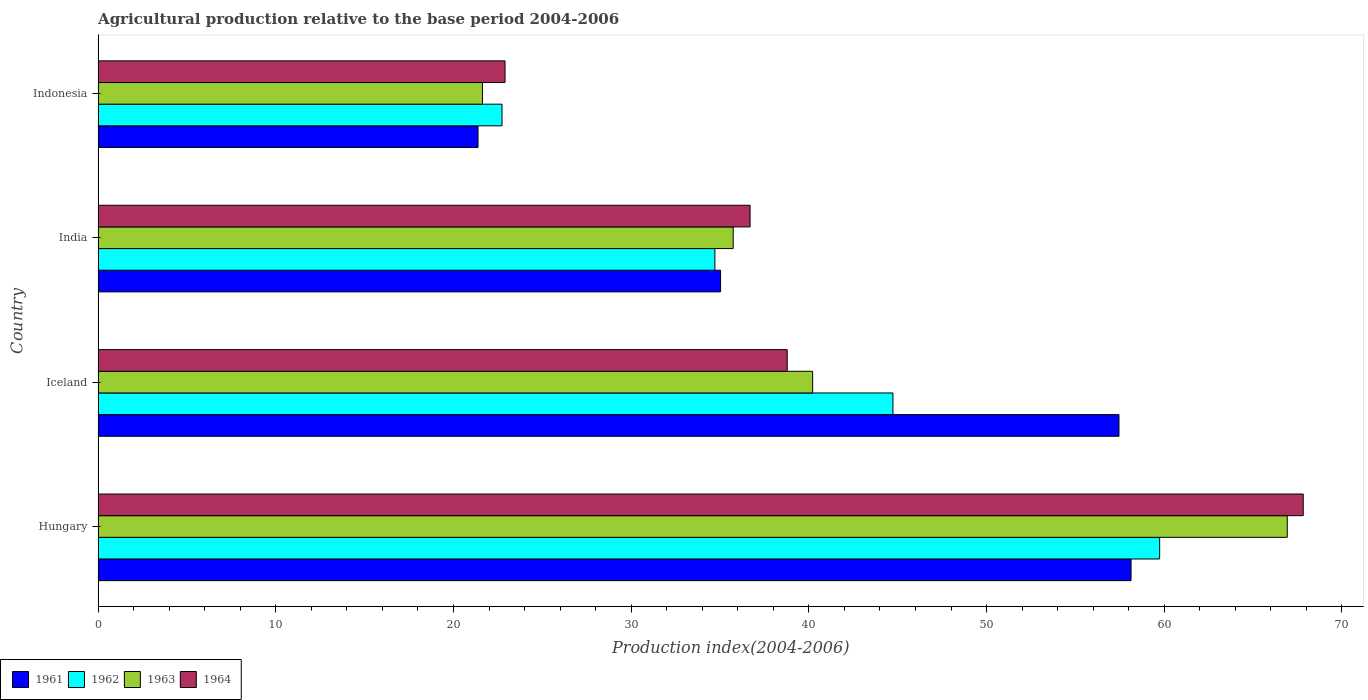How many different coloured bars are there?
Offer a terse response. 4. Are the number of bars on each tick of the Y-axis equal?
Make the answer very short. Yes. How many bars are there on the 4th tick from the top?
Give a very brief answer. 4. What is the label of the 4th group of bars from the top?
Offer a terse response. Hungary. In how many cases, is the number of bars for a given country not equal to the number of legend labels?
Provide a succinct answer. 0. What is the agricultural production index in 1963 in Indonesia?
Your response must be concise. 21.63. Across all countries, what is the maximum agricultural production index in 1962?
Make the answer very short. 59.74. Across all countries, what is the minimum agricultural production index in 1963?
Provide a short and direct response. 21.63. In which country was the agricultural production index in 1962 maximum?
Offer a very short reply. Hungary. In which country was the agricultural production index in 1961 minimum?
Offer a very short reply. Indonesia. What is the total agricultural production index in 1962 in the graph?
Make the answer very short. 161.91. What is the difference between the agricultural production index in 1961 in India and that in Indonesia?
Offer a very short reply. 13.65. What is the difference between the agricultural production index in 1963 in Hungary and the agricultural production index in 1962 in Indonesia?
Your response must be concise. 44.19. What is the average agricultural production index in 1963 per country?
Your answer should be very brief. 41.12. What is the difference between the agricultural production index in 1963 and agricultural production index in 1961 in Indonesia?
Offer a terse response. 0.25. What is the ratio of the agricultural production index in 1964 in Iceland to that in India?
Give a very brief answer. 1.06. What is the difference between the highest and the second highest agricultural production index in 1962?
Make the answer very short. 15.01. What is the difference between the highest and the lowest agricultural production index in 1963?
Provide a short and direct response. 45.29. In how many countries, is the agricultural production index in 1961 greater than the average agricultural production index in 1961 taken over all countries?
Offer a terse response. 2. Is the sum of the agricultural production index in 1964 in Hungary and India greater than the maximum agricultural production index in 1961 across all countries?
Provide a short and direct response. Yes. Is it the case that in every country, the sum of the agricultural production index in 1961 and agricultural production index in 1963 is greater than the sum of agricultural production index in 1964 and agricultural production index in 1962?
Your answer should be compact. No. What does the 2nd bar from the bottom in Iceland represents?
Make the answer very short. 1962. Are all the bars in the graph horizontal?
Keep it short and to the point. Yes. Does the graph contain any zero values?
Your response must be concise. No. Where does the legend appear in the graph?
Ensure brevity in your answer.  Bottom left. How are the legend labels stacked?
Ensure brevity in your answer.  Horizontal. What is the title of the graph?
Your answer should be compact. Agricultural production relative to the base period 2004-2006. What is the label or title of the X-axis?
Offer a very short reply. Production index(2004-2006). What is the label or title of the Y-axis?
Offer a very short reply. Country. What is the Production index(2004-2006) of 1961 in Hungary?
Offer a terse response. 58.13. What is the Production index(2004-2006) in 1962 in Hungary?
Make the answer very short. 59.74. What is the Production index(2004-2006) in 1963 in Hungary?
Keep it short and to the point. 66.92. What is the Production index(2004-2006) of 1964 in Hungary?
Make the answer very short. 67.82. What is the Production index(2004-2006) of 1961 in Iceland?
Provide a succinct answer. 57.45. What is the Production index(2004-2006) of 1962 in Iceland?
Offer a very short reply. 44.73. What is the Production index(2004-2006) in 1963 in Iceland?
Your answer should be compact. 40.21. What is the Production index(2004-2006) in 1964 in Iceland?
Your answer should be compact. 38.78. What is the Production index(2004-2006) in 1961 in India?
Offer a very short reply. 35.03. What is the Production index(2004-2006) of 1962 in India?
Your answer should be very brief. 34.71. What is the Production index(2004-2006) of 1963 in India?
Offer a very short reply. 35.74. What is the Production index(2004-2006) of 1964 in India?
Offer a very short reply. 36.69. What is the Production index(2004-2006) of 1961 in Indonesia?
Offer a very short reply. 21.38. What is the Production index(2004-2006) in 1962 in Indonesia?
Provide a succinct answer. 22.73. What is the Production index(2004-2006) in 1963 in Indonesia?
Offer a very short reply. 21.63. What is the Production index(2004-2006) in 1964 in Indonesia?
Your response must be concise. 22.9. Across all countries, what is the maximum Production index(2004-2006) of 1961?
Keep it short and to the point. 58.13. Across all countries, what is the maximum Production index(2004-2006) in 1962?
Provide a short and direct response. 59.74. Across all countries, what is the maximum Production index(2004-2006) in 1963?
Offer a very short reply. 66.92. Across all countries, what is the maximum Production index(2004-2006) of 1964?
Your answer should be very brief. 67.82. Across all countries, what is the minimum Production index(2004-2006) in 1961?
Keep it short and to the point. 21.38. Across all countries, what is the minimum Production index(2004-2006) of 1962?
Your response must be concise. 22.73. Across all countries, what is the minimum Production index(2004-2006) of 1963?
Provide a succinct answer. 21.63. Across all countries, what is the minimum Production index(2004-2006) of 1964?
Offer a very short reply. 22.9. What is the total Production index(2004-2006) in 1961 in the graph?
Ensure brevity in your answer.  171.99. What is the total Production index(2004-2006) of 1962 in the graph?
Make the answer very short. 161.91. What is the total Production index(2004-2006) of 1963 in the graph?
Keep it short and to the point. 164.5. What is the total Production index(2004-2006) in 1964 in the graph?
Keep it short and to the point. 166.19. What is the difference between the Production index(2004-2006) of 1961 in Hungary and that in Iceland?
Offer a very short reply. 0.68. What is the difference between the Production index(2004-2006) of 1962 in Hungary and that in Iceland?
Make the answer very short. 15.01. What is the difference between the Production index(2004-2006) in 1963 in Hungary and that in Iceland?
Your answer should be very brief. 26.71. What is the difference between the Production index(2004-2006) of 1964 in Hungary and that in Iceland?
Provide a short and direct response. 29.04. What is the difference between the Production index(2004-2006) in 1961 in Hungary and that in India?
Keep it short and to the point. 23.1. What is the difference between the Production index(2004-2006) in 1962 in Hungary and that in India?
Provide a short and direct response. 25.03. What is the difference between the Production index(2004-2006) of 1963 in Hungary and that in India?
Make the answer very short. 31.18. What is the difference between the Production index(2004-2006) of 1964 in Hungary and that in India?
Your answer should be very brief. 31.13. What is the difference between the Production index(2004-2006) of 1961 in Hungary and that in Indonesia?
Provide a short and direct response. 36.75. What is the difference between the Production index(2004-2006) of 1962 in Hungary and that in Indonesia?
Offer a terse response. 37.01. What is the difference between the Production index(2004-2006) of 1963 in Hungary and that in Indonesia?
Your answer should be compact. 45.29. What is the difference between the Production index(2004-2006) in 1964 in Hungary and that in Indonesia?
Provide a succinct answer. 44.92. What is the difference between the Production index(2004-2006) of 1961 in Iceland and that in India?
Provide a short and direct response. 22.42. What is the difference between the Production index(2004-2006) of 1962 in Iceland and that in India?
Your answer should be very brief. 10.02. What is the difference between the Production index(2004-2006) of 1963 in Iceland and that in India?
Give a very brief answer. 4.47. What is the difference between the Production index(2004-2006) in 1964 in Iceland and that in India?
Keep it short and to the point. 2.09. What is the difference between the Production index(2004-2006) in 1961 in Iceland and that in Indonesia?
Offer a terse response. 36.07. What is the difference between the Production index(2004-2006) in 1963 in Iceland and that in Indonesia?
Provide a succinct answer. 18.58. What is the difference between the Production index(2004-2006) of 1964 in Iceland and that in Indonesia?
Offer a terse response. 15.88. What is the difference between the Production index(2004-2006) in 1961 in India and that in Indonesia?
Offer a very short reply. 13.65. What is the difference between the Production index(2004-2006) in 1962 in India and that in Indonesia?
Your response must be concise. 11.98. What is the difference between the Production index(2004-2006) of 1963 in India and that in Indonesia?
Ensure brevity in your answer.  14.11. What is the difference between the Production index(2004-2006) of 1964 in India and that in Indonesia?
Provide a succinct answer. 13.79. What is the difference between the Production index(2004-2006) in 1961 in Hungary and the Production index(2004-2006) in 1962 in Iceland?
Ensure brevity in your answer.  13.4. What is the difference between the Production index(2004-2006) of 1961 in Hungary and the Production index(2004-2006) of 1963 in Iceland?
Offer a very short reply. 17.92. What is the difference between the Production index(2004-2006) of 1961 in Hungary and the Production index(2004-2006) of 1964 in Iceland?
Offer a terse response. 19.35. What is the difference between the Production index(2004-2006) of 1962 in Hungary and the Production index(2004-2006) of 1963 in Iceland?
Make the answer very short. 19.53. What is the difference between the Production index(2004-2006) in 1962 in Hungary and the Production index(2004-2006) in 1964 in Iceland?
Offer a very short reply. 20.96. What is the difference between the Production index(2004-2006) of 1963 in Hungary and the Production index(2004-2006) of 1964 in Iceland?
Your answer should be compact. 28.14. What is the difference between the Production index(2004-2006) of 1961 in Hungary and the Production index(2004-2006) of 1962 in India?
Give a very brief answer. 23.42. What is the difference between the Production index(2004-2006) of 1961 in Hungary and the Production index(2004-2006) of 1963 in India?
Your answer should be very brief. 22.39. What is the difference between the Production index(2004-2006) in 1961 in Hungary and the Production index(2004-2006) in 1964 in India?
Give a very brief answer. 21.44. What is the difference between the Production index(2004-2006) of 1962 in Hungary and the Production index(2004-2006) of 1963 in India?
Your response must be concise. 24. What is the difference between the Production index(2004-2006) of 1962 in Hungary and the Production index(2004-2006) of 1964 in India?
Provide a short and direct response. 23.05. What is the difference between the Production index(2004-2006) of 1963 in Hungary and the Production index(2004-2006) of 1964 in India?
Offer a very short reply. 30.23. What is the difference between the Production index(2004-2006) of 1961 in Hungary and the Production index(2004-2006) of 1962 in Indonesia?
Offer a terse response. 35.4. What is the difference between the Production index(2004-2006) of 1961 in Hungary and the Production index(2004-2006) of 1963 in Indonesia?
Provide a short and direct response. 36.5. What is the difference between the Production index(2004-2006) of 1961 in Hungary and the Production index(2004-2006) of 1964 in Indonesia?
Provide a succinct answer. 35.23. What is the difference between the Production index(2004-2006) of 1962 in Hungary and the Production index(2004-2006) of 1963 in Indonesia?
Your response must be concise. 38.11. What is the difference between the Production index(2004-2006) of 1962 in Hungary and the Production index(2004-2006) of 1964 in Indonesia?
Offer a terse response. 36.84. What is the difference between the Production index(2004-2006) of 1963 in Hungary and the Production index(2004-2006) of 1964 in Indonesia?
Your response must be concise. 44.02. What is the difference between the Production index(2004-2006) in 1961 in Iceland and the Production index(2004-2006) in 1962 in India?
Make the answer very short. 22.74. What is the difference between the Production index(2004-2006) of 1961 in Iceland and the Production index(2004-2006) of 1963 in India?
Your answer should be compact. 21.71. What is the difference between the Production index(2004-2006) of 1961 in Iceland and the Production index(2004-2006) of 1964 in India?
Make the answer very short. 20.76. What is the difference between the Production index(2004-2006) in 1962 in Iceland and the Production index(2004-2006) in 1963 in India?
Your answer should be compact. 8.99. What is the difference between the Production index(2004-2006) in 1962 in Iceland and the Production index(2004-2006) in 1964 in India?
Ensure brevity in your answer.  8.04. What is the difference between the Production index(2004-2006) of 1963 in Iceland and the Production index(2004-2006) of 1964 in India?
Ensure brevity in your answer.  3.52. What is the difference between the Production index(2004-2006) of 1961 in Iceland and the Production index(2004-2006) of 1962 in Indonesia?
Make the answer very short. 34.72. What is the difference between the Production index(2004-2006) of 1961 in Iceland and the Production index(2004-2006) of 1963 in Indonesia?
Provide a succinct answer. 35.82. What is the difference between the Production index(2004-2006) in 1961 in Iceland and the Production index(2004-2006) in 1964 in Indonesia?
Your response must be concise. 34.55. What is the difference between the Production index(2004-2006) of 1962 in Iceland and the Production index(2004-2006) of 1963 in Indonesia?
Ensure brevity in your answer.  23.1. What is the difference between the Production index(2004-2006) of 1962 in Iceland and the Production index(2004-2006) of 1964 in Indonesia?
Ensure brevity in your answer.  21.83. What is the difference between the Production index(2004-2006) in 1963 in Iceland and the Production index(2004-2006) in 1964 in Indonesia?
Give a very brief answer. 17.31. What is the difference between the Production index(2004-2006) of 1961 in India and the Production index(2004-2006) of 1964 in Indonesia?
Give a very brief answer. 12.13. What is the difference between the Production index(2004-2006) in 1962 in India and the Production index(2004-2006) in 1963 in Indonesia?
Your response must be concise. 13.08. What is the difference between the Production index(2004-2006) of 1962 in India and the Production index(2004-2006) of 1964 in Indonesia?
Give a very brief answer. 11.81. What is the difference between the Production index(2004-2006) of 1963 in India and the Production index(2004-2006) of 1964 in Indonesia?
Your response must be concise. 12.84. What is the average Production index(2004-2006) of 1961 per country?
Provide a short and direct response. 43. What is the average Production index(2004-2006) in 1962 per country?
Your response must be concise. 40.48. What is the average Production index(2004-2006) of 1963 per country?
Offer a very short reply. 41.12. What is the average Production index(2004-2006) in 1964 per country?
Provide a short and direct response. 41.55. What is the difference between the Production index(2004-2006) in 1961 and Production index(2004-2006) in 1962 in Hungary?
Offer a terse response. -1.61. What is the difference between the Production index(2004-2006) of 1961 and Production index(2004-2006) of 1963 in Hungary?
Make the answer very short. -8.79. What is the difference between the Production index(2004-2006) of 1961 and Production index(2004-2006) of 1964 in Hungary?
Keep it short and to the point. -9.69. What is the difference between the Production index(2004-2006) in 1962 and Production index(2004-2006) in 1963 in Hungary?
Provide a succinct answer. -7.18. What is the difference between the Production index(2004-2006) of 1962 and Production index(2004-2006) of 1964 in Hungary?
Your answer should be compact. -8.08. What is the difference between the Production index(2004-2006) of 1961 and Production index(2004-2006) of 1962 in Iceland?
Your response must be concise. 12.72. What is the difference between the Production index(2004-2006) of 1961 and Production index(2004-2006) of 1963 in Iceland?
Give a very brief answer. 17.24. What is the difference between the Production index(2004-2006) in 1961 and Production index(2004-2006) in 1964 in Iceland?
Keep it short and to the point. 18.67. What is the difference between the Production index(2004-2006) of 1962 and Production index(2004-2006) of 1963 in Iceland?
Keep it short and to the point. 4.52. What is the difference between the Production index(2004-2006) of 1962 and Production index(2004-2006) of 1964 in Iceland?
Give a very brief answer. 5.95. What is the difference between the Production index(2004-2006) of 1963 and Production index(2004-2006) of 1964 in Iceland?
Your answer should be very brief. 1.43. What is the difference between the Production index(2004-2006) of 1961 and Production index(2004-2006) of 1962 in India?
Ensure brevity in your answer.  0.32. What is the difference between the Production index(2004-2006) of 1961 and Production index(2004-2006) of 1963 in India?
Your answer should be very brief. -0.71. What is the difference between the Production index(2004-2006) in 1961 and Production index(2004-2006) in 1964 in India?
Your response must be concise. -1.66. What is the difference between the Production index(2004-2006) in 1962 and Production index(2004-2006) in 1963 in India?
Ensure brevity in your answer.  -1.03. What is the difference between the Production index(2004-2006) of 1962 and Production index(2004-2006) of 1964 in India?
Your response must be concise. -1.98. What is the difference between the Production index(2004-2006) in 1963 and Production index(2004-2006) in 1964 in India?
Provide a succinct answer. -0.95. What is the difference between the Production index(2004-2006) in 1961 and Production index(2004-2006) in 1962 in Indonesia?
Offer a terse response. -1.35. What is the difference between the Production index(2004-2006) of 1961 and Production index(2004-2006) of 1963 in Indonesia?
Your answer should be compact. -0.25. What is the difference between the Production index(2004-2006) in 1961 and Production index(2004-2006) in 1964 in Indonesia?
Keep it short and to the point. -1.52. What is the difference between the Production index(2004-2006) in 1962 and Production index(2004-2006) in 1963 in Indonesia?
Ensure brevity in your answer.  1.1. What is the difference between the Production index(2004-2006) in 1962 and Production index(2004-2006) in 1964 in Indonesia?
Your response must be concise. -0.17. What is the difference between the Production index(2004-2006) in 1963 and Production index(2004-2006) in 1964 in Indonesia?
Your response must be concise. -1.27. What is the ratio of the Production index(2004-2006) of 1961 in Hungary to that in Iceland?
Provide a succinct answer. 1.01. What is the ratio of the Production index(2004-2006) in 1962 in Hungary to that in Iceland?
Your answer should be compact. 1.34. What is the ratio of the Production index(2004-2006) in 1963 in Hungary to that in Iceland?
Your answer should be compact. 1.66. What is the ratio of the Production index(2004-2006) of 1964 in Hungary to that in Iceland?
Offer a terse response. 1.75. What is the ratio of the Production index(2004-2006) in 1961 in Hungary to that in India?
Offer a very short reply. 1.66. What is the ratio of the Production index(2004-2006) in 1962 in Hungary to that in India?
Keep it short and to the point. 1.72. What is the ratio of the Production index(2004-2006) in 1963 in Hungary to that in India?
Give a very brief answer. 1.87. What is the ratio of the Production index(2004-2006) in 1964 in Hungary to that in India?
Offer a terse response. 1.85. What is the ratio of the Production index(2004-2006) of 1961 in Hungary to that in Indonesia?
Offer a terse response. 2.72. What is the ratio of the Production index(2004-2006) in 1962 in Hungary to that in Indonesia?
Ensure brevity in your answer.  2.63. What is the ratio of the Production index(2004-2006) of 1963 in Hungary to that in Indonesia?
Provide a succinct answer. 3.09. What is the ratio of the Production index(2004-2006) of 1964 in Hungary to that in Indonesia?
Offer a very short reply. 2.96. What is the ratio of the Production index(2004-2006) of 1961 in Iceland to that in India?
Your answer should be very brief. 1.64. What is the ratio of the Production index(2004-2006) in 1962 in Iceland to that in India?
Offer a very short reply. 1.29. What is the ratio of the Production index(2004-2006) of 1963 in Iceland to that in India?
Your answer should be very brief. 1.13. What is the ratio of the Production index(2004-2006) of 1964 in Iceland to that in India?
Your response must be concise. 1.06. What is the ratio of the Production index(2004-2006) of 1961 in Iceland to that in Indonesia?
Offer a very short reply. 2.69. What is the ratio of the Production index(2004-2006) of 1962 in Iceland to that in Indonesia?
Offer a very short reply. 1.97. What is the ratio of the Production index(2004-2006) of 1963 in Iceland to that in Indonesia?
Your answer should be compact. 1.86. What is the ratio of the Production index(2004-2006) in 1964 in Iceland to that in Indonesia?
Give a very brief answer. 1.69. What is the ratio of the Production index(2004-2006) of 1961 in India to that in Indonesia?
Give a very brief answer. 1.64. What is the ratio of the Production index(2004-2006) of 1962 in India to that in Indonesia?
Keep it short and to the point. 1.53. What is the ratio of the Production index(2004-2006) of 1963 in India to that in Indonesia?
Your answer should be compact. 1.65. What is the ratio of the Production index(2004-2006) of 1964 in India to that in Indonesia?
Your answer should be very brief. 1.6. What is the difference between the highest and the second highest Production index(2004-2006) in 1961?
Give a very brief answer. 0.68. What is the difference between the highest and the second highest Production index(2004-2006) of 1962?
Your answer should be compact. 15.01. What is the difference between the highest and the second highest Production index(2004-2006) in 1963?
Keep it short and to the point. 26.71. What is the difference between the highest and the second highest Production index(2004-2006) in 1964?
Offer a terse response. 29.04. What is the difference between the highest and the lowest Production index(2004-2006) in 1961?
Offer a terse response. 36.75. What is the difference between the highest and the lowest Production index(2004-2006) in 1962?
Offer a very short reply. 37.01. What is the difference between the highest and the lowest Production index(2004-2006) in 1963?
Your answer should be very brief. 45.29. What is the difference between the highest and the lowest Production index(2004-2006) in 1964?
Offer a terse response. 44.92. 